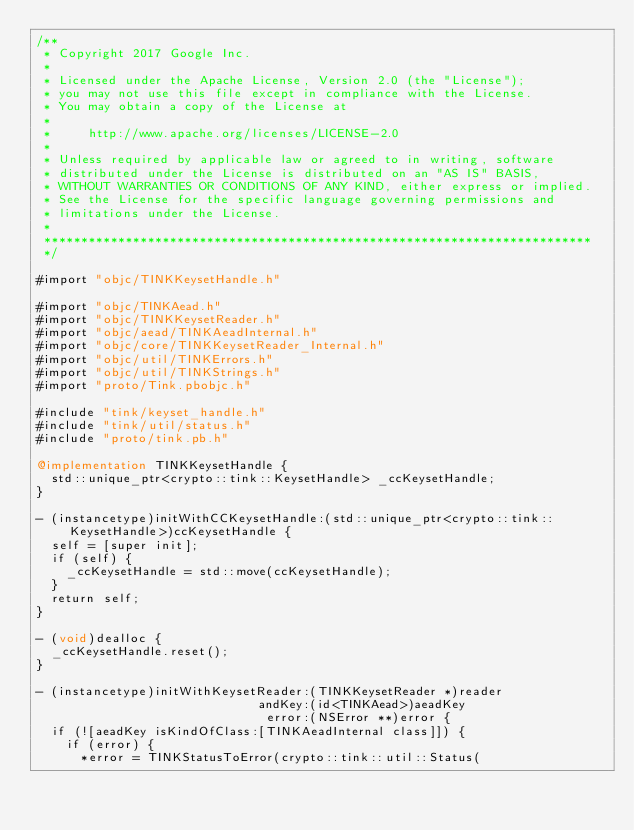<code> <loc_0><loc_0><loc_500><loc_500><_ObjectiveC_>/**
 * Copyright 2017 Google Inc.
 *
 * Licensed under the Apache License, Version 2.0 (the "License");
 * you may not use this file except in compliance with the License.
 * You may obtain a copy of the License at
 *
 *     http://www.apache.org/licenses/LICENSE-2.0
 *
 * Unless required by applicable law or agreed to in writing, software
 * distributed under the License is distributed on an "AS IS" BASIS,
 * WITHOUT WARRANTIES OR CONDITIONS OF ANY KIND, either express or implied.
 * See the License for the specific language governing permissions and
 * limitations under the License.
 *
 **************************************************************************
 */

#import "objc/TINKKeysetHandle.h"

#import "objc/TINKAead.h"
#import "objc/TINKKeysetReader.h"
#import "objc/aead/TINKAeadInternal.h"
#import "objc/core/TINKKeysetReader_Internal.h"
#import "objc/util/TINKErrors.h"
#import "objc/util/TINKStrings.h"
#import "proto/Tink.pbobjc.h"

#include "tink/keyset_handle.h"
#include "tink/util/status.h"
#include "proto/tink.pb.h"

@implementation TINKKeysetHandle {
  std::unique_ptr<crypto::tink::KeysetHandle> _ccKeysetHandle;
}

- (instancetype)initWithCCKeysetHandle:(std::unique_ptr<crypto::tink::KeysetHandle>)ccKeysetHandle {
  self = [super init];
  if (self) {
    _ccKeysetHandle = std::move(ccKeysetHandle);
  }
  return self;
}

- (void)dealloc {
  _ccKeysetHandle.reset();
}

- (instancetype)initWithKeysetReader:(TINKKeysetReader *)reader
                              andKey:(id<TINKAead>)aeadKey
                               error:(NSError **)error {
  if (![aeadKey isKindOfClass:[TINKAeadInternal class]]) {
    if (error) {
      *error = TINKStatusToError(crypto::tink::util::Status(</code> 